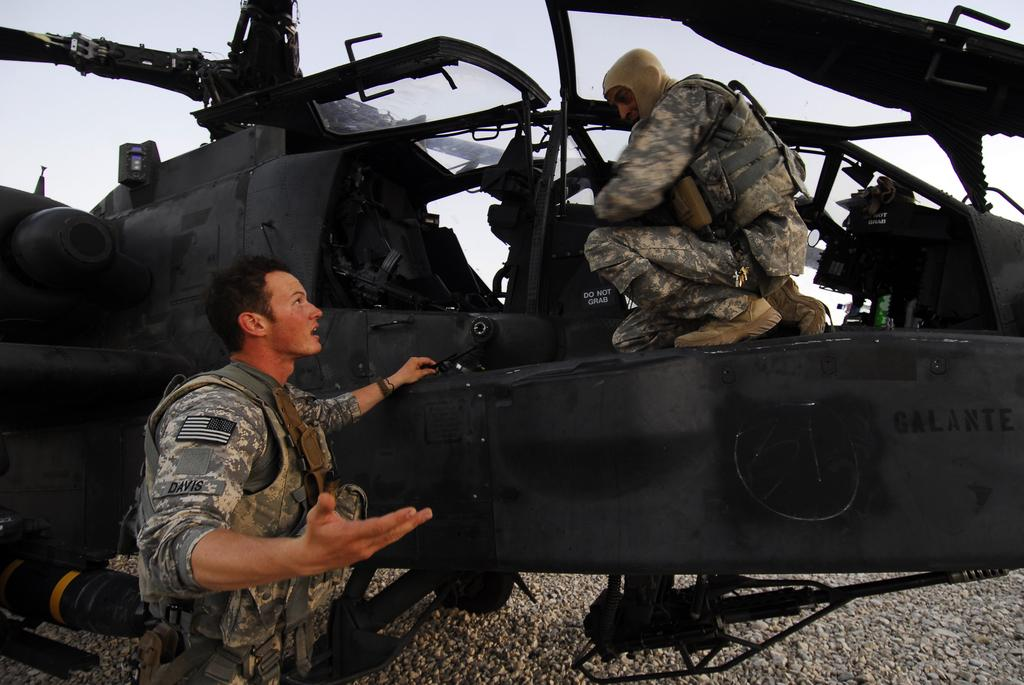How many people are in the image? There are two men in the image. What are the men wearing? Both men are wearing uniforms. Where is one of the men located? One man is standing on the ground. Where is the other man located? The other man is on a helicopter. What can be seen in the background of the image? The sky is visible in the background of the image. What type of sack is being used to transport the rate on the helicopter? There is no sack or rate present in the image; it features two men, one on the ground and the other on a helicopter. 